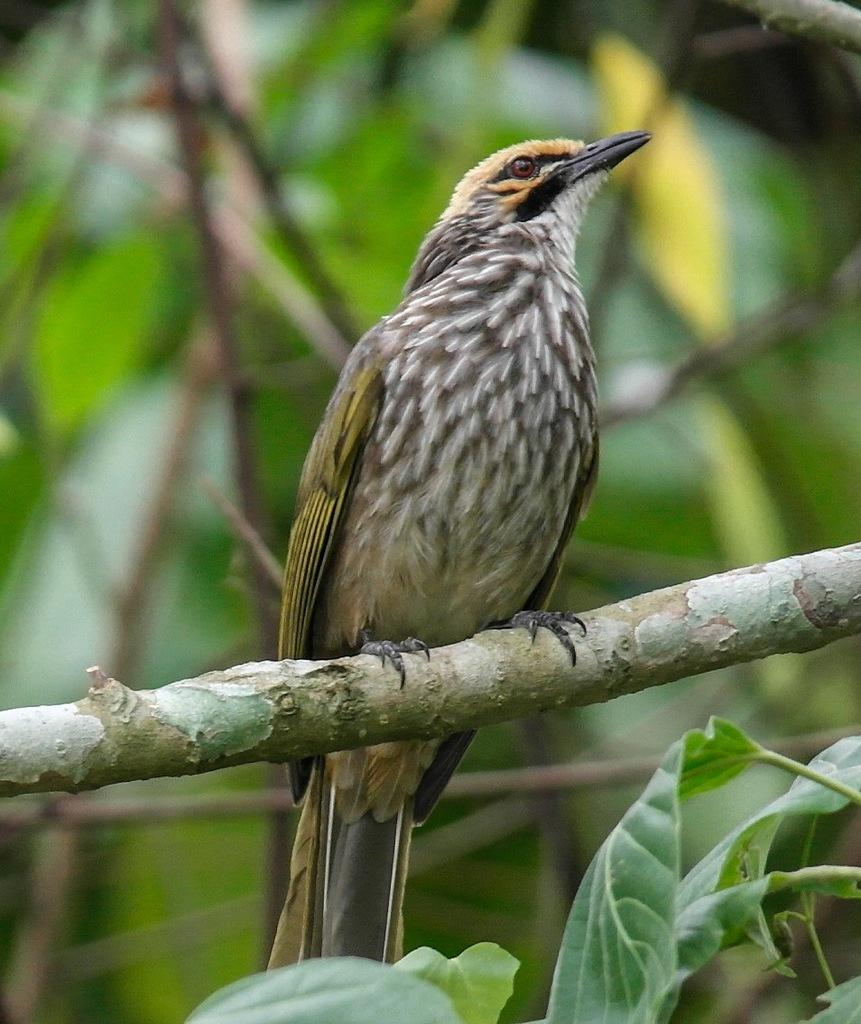What type of animal is in the image? There is a bird in the image. Can you describe the bird's appearance? The bird has cream, black, orange, and yellow coloring. Where is the bird located in the image? The bird is on a tree branch. What can be said about the background of the image? The background of the image is blurry, and the background colors are green, brown, and yellow. What type of vase is visible in the image? There is no vase present in the image; it features a bird on a tree branch. What event is taking place in the image? There is no specific event depicted in the image; it simply shows a bird on a tree branch. 